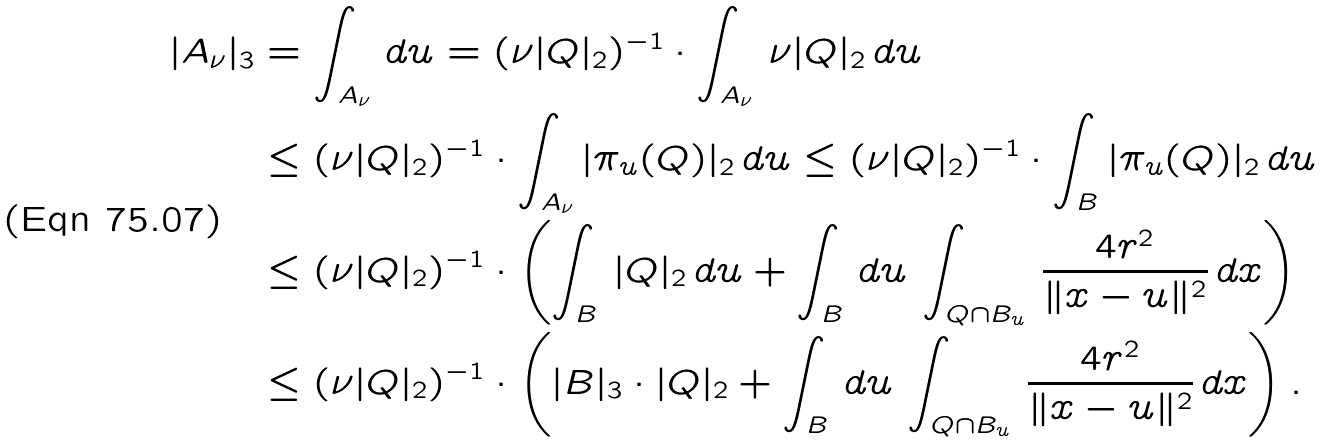<formula> <loc_0><loc_0><loc_500><loc_500>| A _ { \nu } | _ { 3 } & = \int _ { A _ { \nu } } \, d u = ( \nu | Q | _ { 2 } ) ^ { - 1 } \cdot \int _ { A _ { \nu } } \, \nu | Q | _ { 2 } \, d u \\ & \leq ( \nu | Q | _ { 2 } ) ^ { - 1 } \cdot \int _ { A _ { \nu } } | \pi _ { u } ( Q ) | _ { 2 } \, d u \leq ( \nu | Q | _ { 2 } ) ^ { - 1 } \cdot \int _ { B } | \pi _ { u } ( Q ) | _ { 2 } \, d u \\ & \leq ( \nu | Q | _ { 2 } ) ^ { - 1 } \cdot \left ( { \int _ { B } \, | Q | _ { 2 } \, d u } + { \int _ { B } \, d u \, \int _ { Q \cap B _ { u } } \, \frac { 4 r ^ { 2 } } { \| x - u \| ^ { 2 } } \, d x } \right ) \\ & \leq ( \nu | Q | _ { 2 } ) ^ { - 1 } \cdot \left ( { | B | _ { 3 } \cdot | Q | _ { 2 } } + { \int _ { B } \, d u \, \int _ { Q \cap B _ { u } } \, \frac { 4 r ^ { 2 } } { \| x - u \| ^ { 2 } } \, d x } \right ) .</formula> 